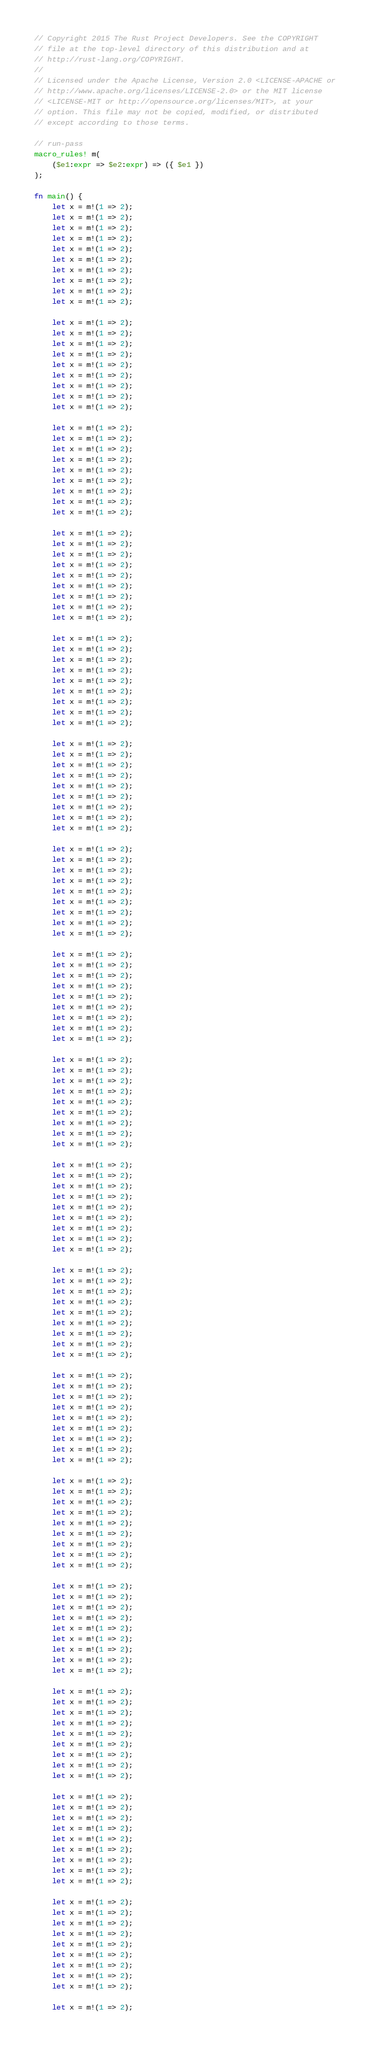Convert code to text. <code><loc_0><loc_0><loc_500><loc_500><_Rust_>// Copyright 2015 The Rust Project Developers. See the COPYRIGHT
// file at the top-level directory of this distribution and at
// http://rust-lang.org/COPYRIGHT.
//
// Licensed under the Apache License, Version 2.0 <LICENSE-APACHE or
// http://www.apache.org/licenses/LICENSE-2.0> or the MIT license
// <LICENSE-MIT or http://opensource.org/licenses/MIT>, at your
// option. This file may not be copied, modified, or distributed
// except according to those terms.

// run-pass
macro_rules! m(
    ($e1:expr => $e2:expr) => ({ $e1 })
);

fn main() {
    let x = m!(1 => 2);
    let x = m!(1 => 2);
    let x = m!(1 => 2);
    let x = m!(1 => 2);
    let x = m!(1 => 2);
    let x = m!(1 => 2);
    let x = m!(1 => 2);
    let x = m!(1 => 2);
    let x = m!(1 => 2);
    let x = m!(1 => 2);

    let x = m!(1 => 2);
    let x = m!(1 => 2);
    let x = m!(1 => 2);
    let x = m!(1 => 2);
    let x = m!(1 => 2);
    let x = m!(1 => 2);
    let x = m!(1 => 2);
    let x = m!(1 => 2);
    let x = m!(1 => 2);

    let x = m!(1 => 2);
    let x = m!(1 => 2);
    let x = m!(1 => 2);
    let x = m!(1 => 2);
    let x = m!(1 => 2);
    let x = m!(1 => 2);
    let x = m!(1 => 2);
    let x = m!(1 => 2);
    let x = m!(1 => 2);

    let x = m!(1 => 2);
    let x = m!(1 => 2);
    let x = m!(1 => 2);
    let x = m!(1 => 2);
    let x = m!(1 => 2);
    let x = m!(1 => 2);
    let x = m!(1 => 2);
    let x = m!(1 => 2);
    let x = m!(1 => 2);

    let x = m!(1 => 2);
    let x = m!(1 => 2);
    let x = m!(1 => 2);
    let x = m!(1 => 2);
    let x = m!(1 => 2);
    let x = m!(1 => 2);
    let x = m!(1 => 2);
    let x = m!(1 => 2);
    let x = m!(1 => 2);

    let x = m!(1 => 2);
    let x = m!(1 => 2);
    let x = m!(1 => 2);
    let x = m!(1 => 2);
    let x = m!(1 => 2);
    let x = m!(1 => 2);
    let x = m!(1 => 2);
    let x = m!(1 => 2);
    let x = m!(1 => 2);

    let x = m!(1 => 2);
    let x = m!(1 => 2);
    let x = m!(1 => 2);
    let x = m!(1 => 2);
    let x = m!(1 => 2);
    let x = m!(1 => 2);
    let x = m!(1 => 2);
    let x = m!(1 => 2);
    let x = m!(1 => 2);

    let x = m!(1 => 2);
    let x = m!(1 => 2);
    let x = m!(1 => 2);
    let x = m!(1 => 2);
    let x = m!(1 => 2);
    let x = m!(1 => 2);
    let x = m!(1 => 2);
    let x = m!(1 => 2);
    let x = m!(1 => 2);

    let x = m!(1 => 2);
    let x = m!(1 => 2);
    let x = m!(1 => 2);
    let x = m!(1 => 2);
    let x = m!(1 => 2);
    let x = m!(1 => 2);
    let x = m!(1 => 2);
    let x = m!(1 => 2);
    let x = m!(1 => 2);

    let x = m!(1 => 2);
    let x = m!(1 => 2);
    let x = m!(1 => 2);
    let x = m!(1 => 2);
    let x = m!(1 => 2);
    let x = m!(1 => 2);
    let x = m!(1 => 2);
    let x = m!(1 => 2);
    let x = m!(1 => 2);

    let x = m!(1 => 2);
    let x = m!(1 => 2);
    let x = m!(1 => 2);
    let x = m!(1 => 2);
    let x = m!(1 => 2);
    let x = m!(1 => 2);
    let x = m!(1 => 2);
    let x = m!(1 => 2);
    let x = m!(1 => 2);

    let x = m!(1 => 2);
    let x = m!(1 => 2);
    let x = m!(1 => 2);
    let x = m!(1 => 2);
    let x = m!(1 => 2);
    let x = m!(1 => 2);
    let x = m!(1 => 2);
    let x = m!(1 => 2);
    let x = m!(1 => 2);

    let x = m!(1 => 2);
    let x = m!(1 => 2);
    let x = m!(1 => 2);
    let x = m!(1 => 2);
    let x = m!(1 => 2);
    let x = m!(1 => 2);
    let x = m!(1 => 2);
    let x = m!(1 => 2);
    let x = m!(1 => 2);

    let x = m!(1 => 2);
    let x = m!(1 => 2);
    let x = m!(1 => 2);
    let x = m!(1 => 2);
    let x = m!(1 => 2);
    let x = m!(1 => 2);
    let x = m!(1 => 2);
    let x = m!(1 => 2);
    let x = m!(1 => 2);

    let x = m!(1 => 2);
    let x = m!(1 => 2);
    let x = m!(1 => 2);
    let x = m!(1 => 2);
    let x = m!(1 => 2);
    let x = m!(1 => 2);
    let x = m!(1 => 2);
    let x = m!(1 => 2);
    let x = m!(1 => 2);

    let x = m!(1 => 2);
    let x = m!(1 => 2);
    let x = m!(1 => 2);
    let x = m!(1 => 2);
    let x = m!(1 => 2);
    let x = m!(1 => 2);
    let x = m!(1 => 2);
    let x = m!(1 => 2);
    let x = m!(1 => 2);

    let x = m!(1 => 2);
    let x = m!(1 => 2);
    let x = m!(1 => 2);
    let x = m!(1 => 2);
    let x = m!(1 => 2);
    let x = m!(1 => 2);
    let x = m!(1 => 2);
    let x = m!(1 => 2);
    let x = m!(1 => 2);

    let x = m!(1 => 2);</code> 